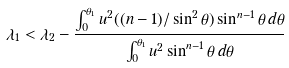<formula> <loc_0><loc_0><loc_500><loc_500>\lambda _ { 1 } < \lambda _ { 2 } - \frac { \int _ { 0 } ^ { \theta _ { 1 } } u ^ { 2 } ( ( n - 1 ) / \sin ^ { 2 } \theta ) \sin ^ { n - 1 } \theta \, d \theta } { \int _ { 0 } ^ { \theta _ { 1 } } u ^ { 2 } \sin ^ { n - 1 } \theta \, d \theta }</formula> 